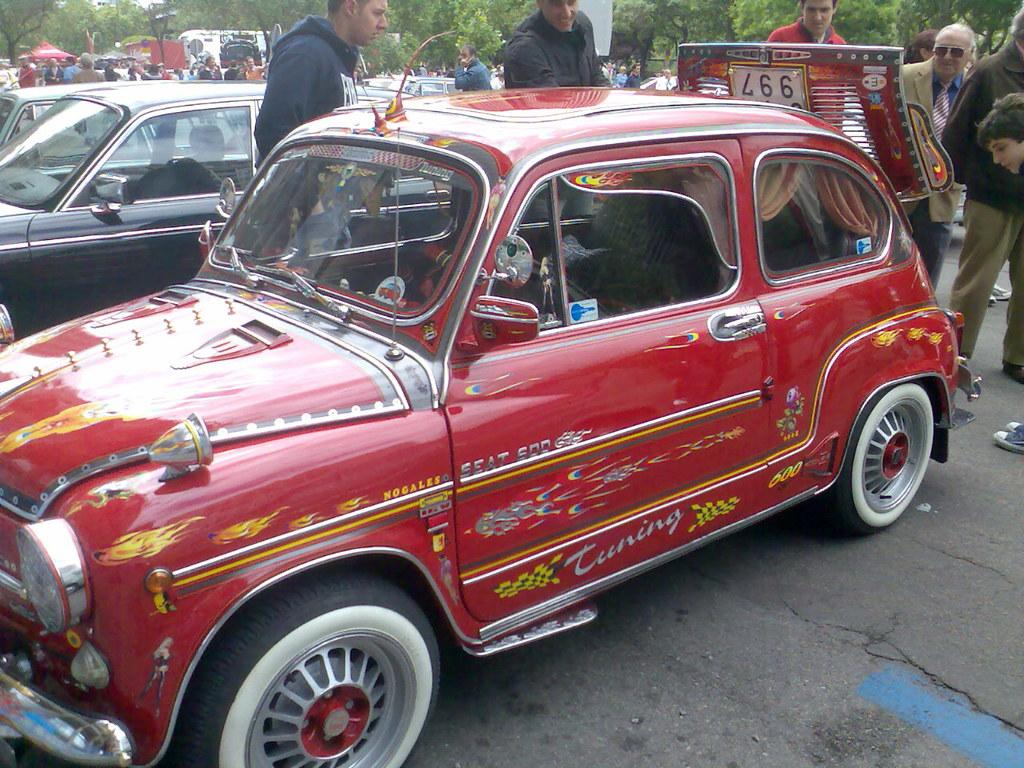Provide a one-sentence caption for the provided image. A vintage Seat 500 features flame decals on the sides. 